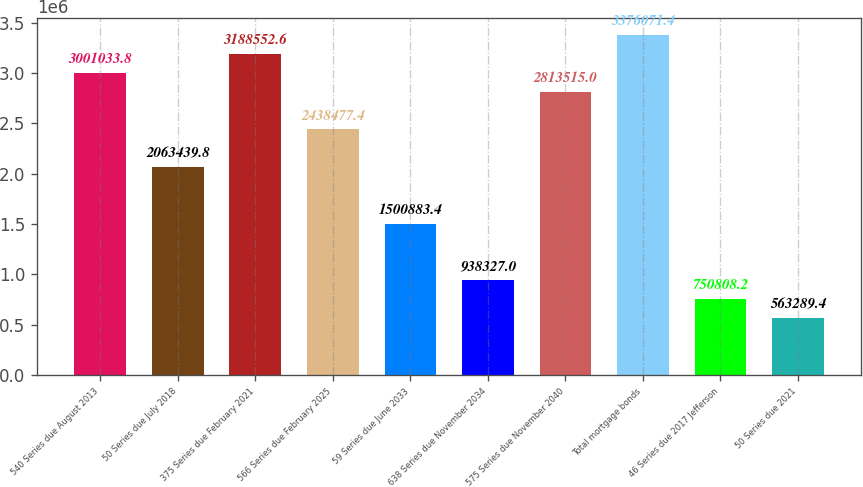Convert chart to OTSL. <chart><loc_0><loc_0><loc_500><loc_500><bar_chart><fcel>540 Series due August 2013<fcel>50 Series due July 2018<fcel>375 Series due February 2021<fcel>566 Series due February 2025<fcel>59 Series due June 2033<fcel>638 Series due November 2034<fcel>575 Series due November 2040<fcel>Total mortgage bonds<fcel>46 Series due 2017 Jefferson<fcel>50 Series due 2021<nl><fcel>3.00103e+06<fcel>2.06344e+06<fcel>3.18855e+06<fcel>2.43848e+06<fcel>1.50088e+06<fcel>938327<fcel>2.81352e+06<fcel>3.37607e+06<fcel>750808<fcel>563289<nl></chart> 